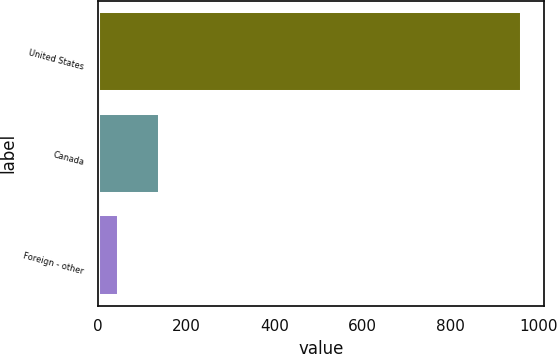<chart> <loc_0><loc_0><loc_500><loc_500><bar_chart><fcel>United States<fcel>Canada<fcel>Foreign - other<nl><fcel>962.6<fcel>139.91<fcel>48.5<nl></chart> 